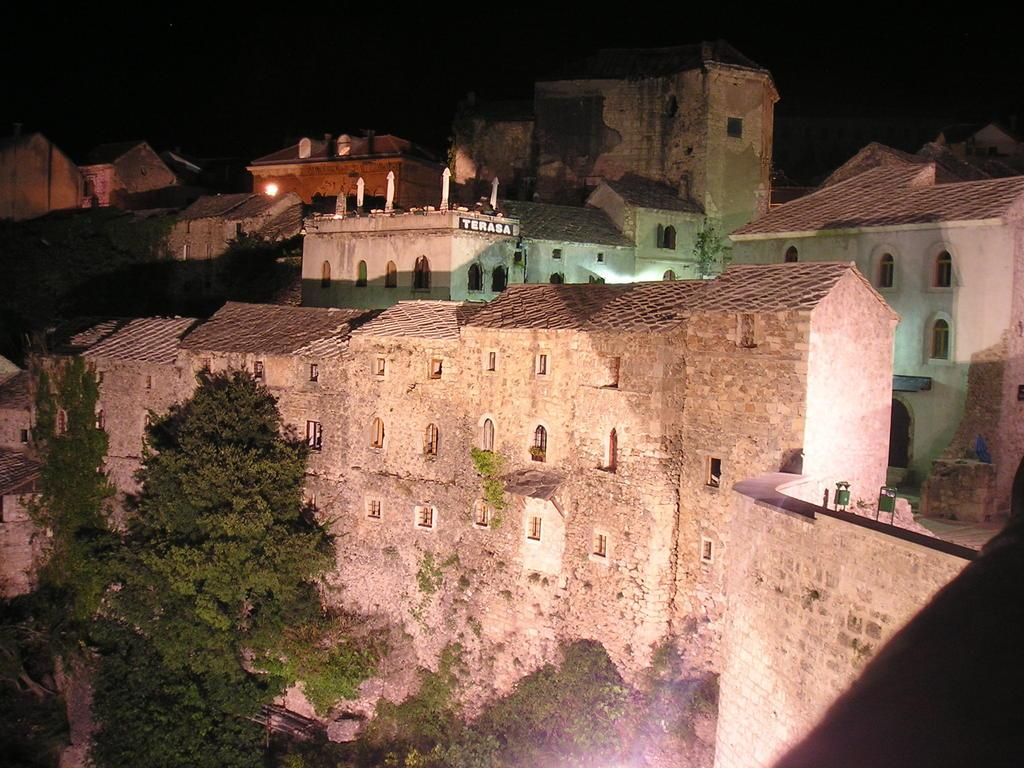What type of natural elements can be seen in the image? There are trees in the image. What type of structures are present in the image? There are buildings with windows in the image. Can you describe any other objects in the image? Yes, there are some objects in the image. What is the color of the background in the image? The background of the image is dark. Can you tell me how many squirrels are climbing the trees in the image? There are no squirrels climbing the trees in the image; only trees and buildings are present. What type of blade is being used to cut the objects in the image? There is no blade present in the image, and no objects are being cut. 